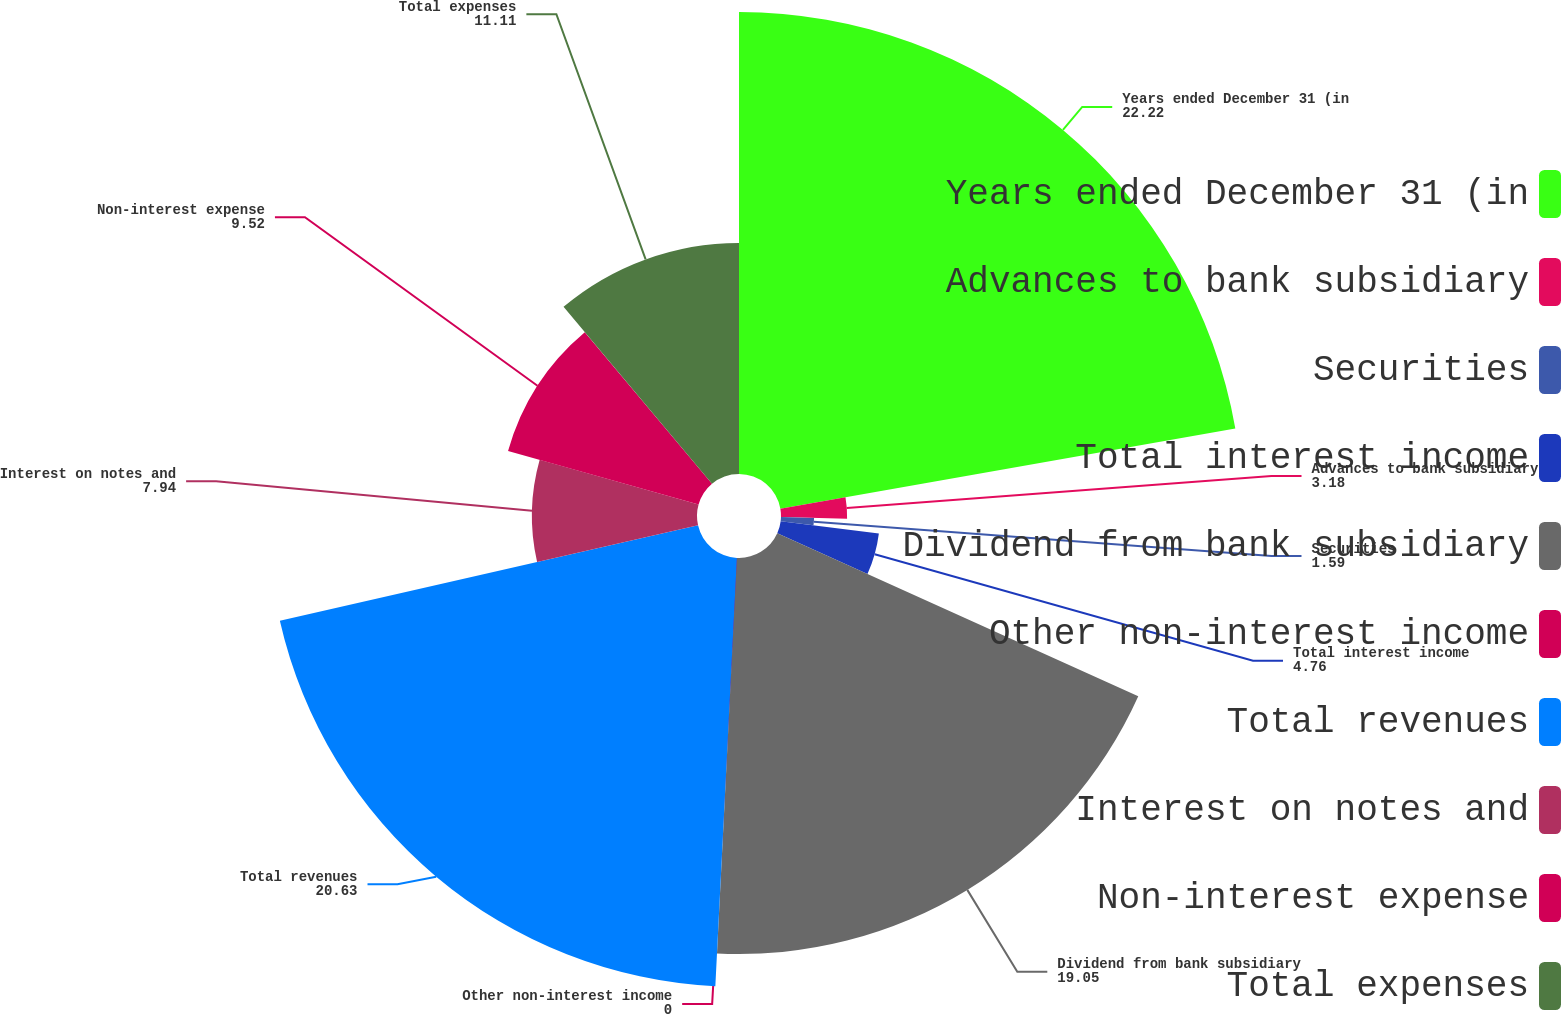<chart> <loc_0><loc_0><loc_500><loc_500><pie_chart><fcel>Years ended December 31 (in<fcel>Advances to bank subsidiary<fcel>Securities<fcel>Total interest income<fcel>Dividend from bank subsidiary<fcel>Other non-interest income<fcel>Total revenues<fcel>Interest on notes and<fcel>Non-interest expense<fcel>Total expenses<nl><fcel>22.22%<fcel>3.18%<fcel>1.59%<fcel>4.76%<fcel>19.05%<fcel>0.0%<fcel>20.63%<fcel>7.94%<fcel>9.52%<fcel>11.11%<nl></chart> 